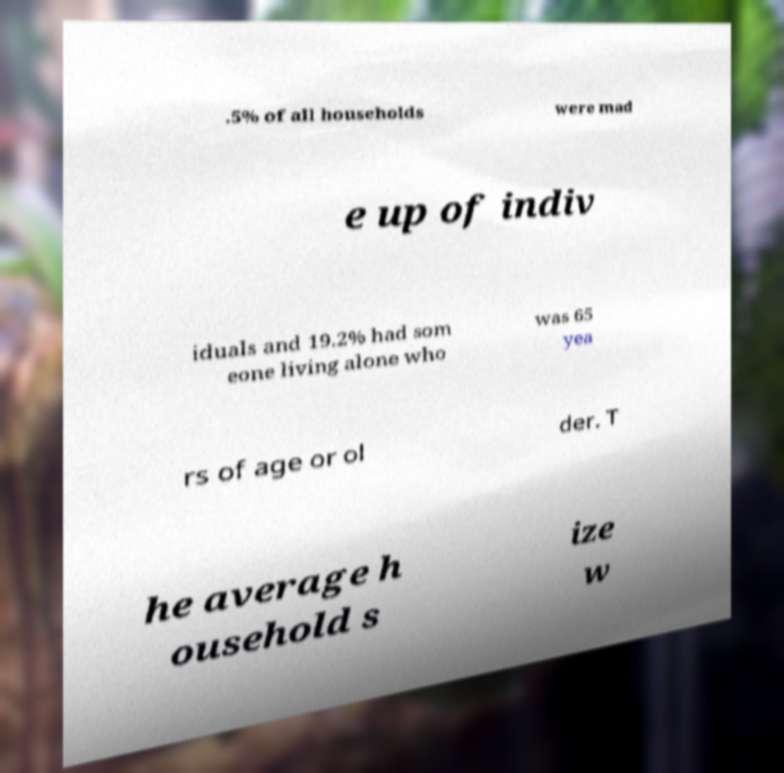Please identify and transcribe the text found in this image. .5% of all households were mad e up of indiv iduals and 19.2% had som eone living alone who was 65 yea rs of age or ol der. T he average h ousehold s ize w 